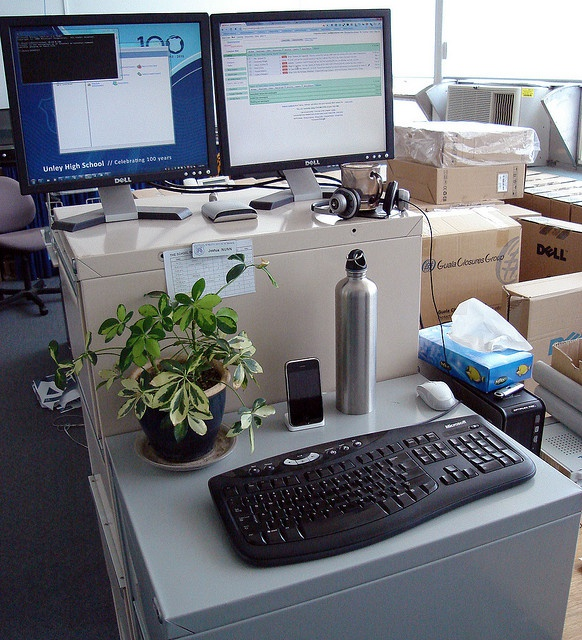Describe the objects in this image and their specific colors. I can see tv in lightgray, black, and navy tones, keyboard in lightgray, black, gray, and blue tones, tv in lightgray, darkgray, and black tones, potted plant in lightgray, black, gray, darkgreen, and darkgray tones, and bottle in lightgray, gray, black, and darkgray tones in this image. 